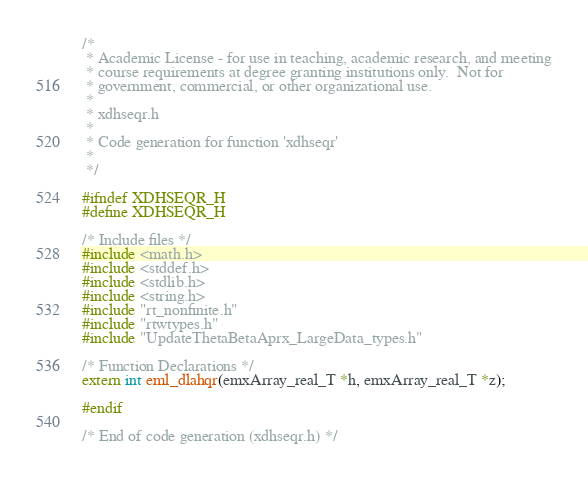Convert code to text. <code><loc_0><loc_0><loc_500><loc_500><_C_>/*
 * Academic License - for use in teaching, academic research, and meeting
 * course requirements at degree granting institutions only.  Not for
 * government, commercial, or other organizational use.
 *
 * xdhseqr.h
 *
 * Code generation for function 'xdhseqr'
 *
 */

#ifndef XDHSEQR_H
#define XDHSEQR_H

/* Include files */
#include <math.h>
#include <stddef.h>
#include <stdlib.h>
#include <string.h>
#include "rt_nonfinite.h"
#include "rtwtypes.h"
#include "UpdateThetaBetaAprx_LargeData_types.h"

/* Function Declarations */
extern int eml_dlahqr(emxArray_real_T *h, emxArray_real_T *z);

#endif

/* End of code generation (xdhseqr.h) */
</code> 